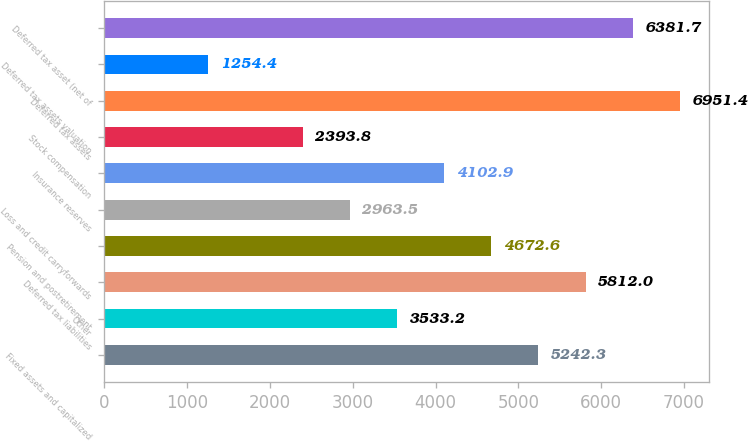Convert chart. <chart><loc_0><loc_0><loc_500><loc_500><bar_chart><fcel>Fixed assets and capitalized<fcel>Other<fcel>Deferred tax liabilities<fcel>Pension and postretirement<fcel>Loss and credit carryforwards<fcel>Insurance reserves<fcel>Stock compensation<fcel>Deferred tax assets<fcel>Deferred tax assets valuation<fcel>Deferred tax asset (net of<nl><fcel>5242.3<fcel>3533.2<fcel>5812<fcel>4672.6<fcel>2963.5<fcel>4102.9<fcel>2393.8<fcel>6951.4<fcel>1254.4<fcel>6381.7<nl></chart> 